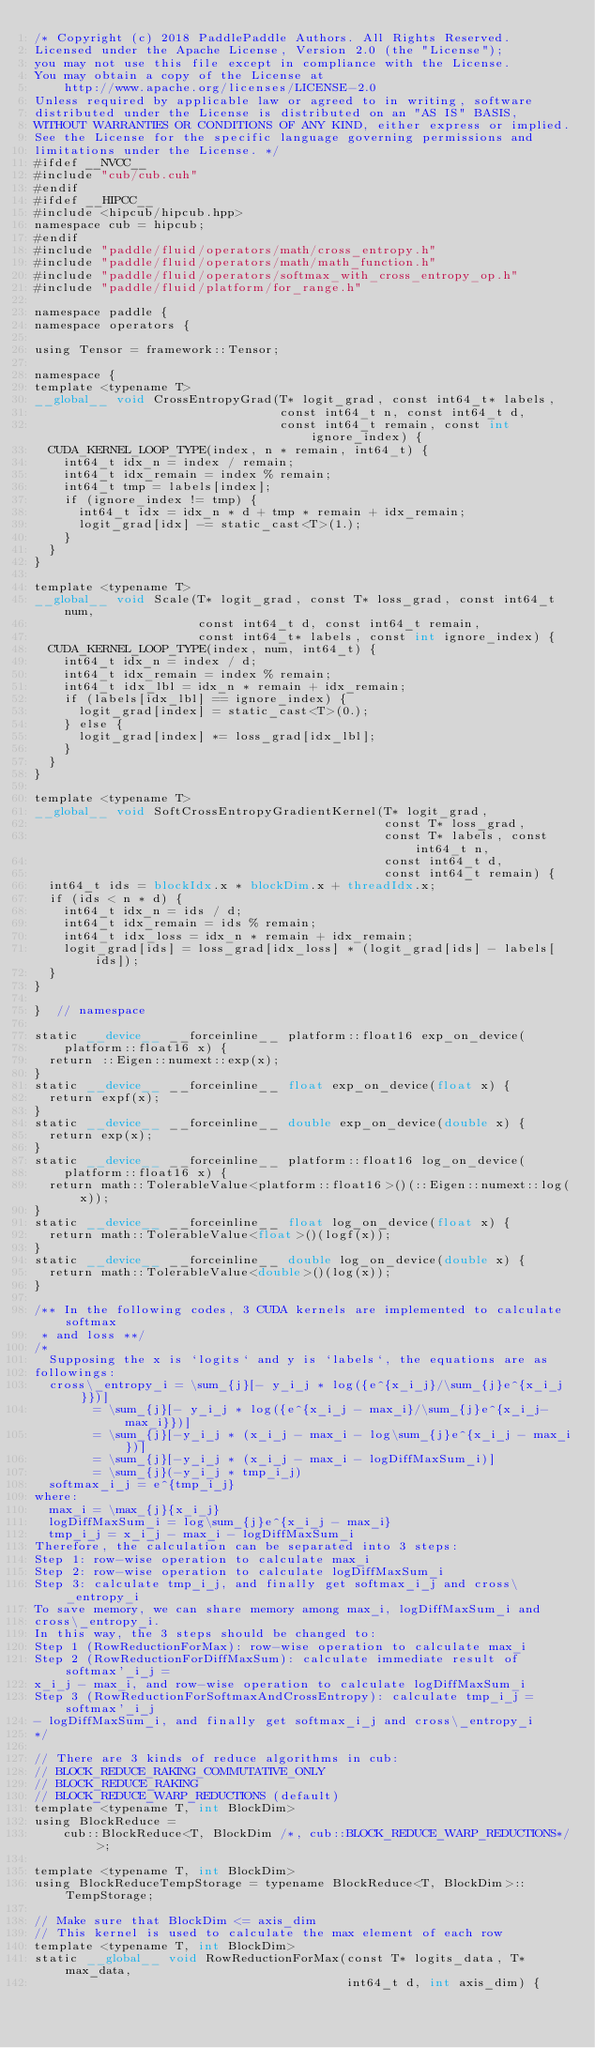<code> <loc_0><loc_0><loc_500><loc_500><_Cuda_>/* Copyright (c) 2018 PaddlePaddle Authors. All Rights Reserved.
Licensed under the Apache License, Version 2.0 (the "License");
you may not use this file except in compliance with the License.
You may obtain a copy of the License at
    http://www.apache.org/licenses/LICENSE-2.0
Unless required by applicable law or agreed to in writing, software
distributed under the License is distributed on an "AS IS" BASIS,
WITHOUT WARRANTIES OR CONDITIONS OF ANY KIND, either express or implied.
See the License for the specific language governing permissions and
limitations under the License. */
#ifdef __NVCC__
#include "cub/cub.cuh"
#endif
#ifdef __HIPCC__
#include <hipcub/hipcub.hpp>
namespace cub = hipcub;
#endif
#include "paddle/fluid/operators/math/cross_entropy.h"
#include "paddle/fluid/operators/math/math_function.h"
#include "paddle/fluid/operators/softmax_with_cross_entropy_op.h"
#include "paddle/fluid/platform/for_range.h"

namespace paddle {
namespace operators {

using Tensor = framework::Tensor;

namespace {
template <typename T>
__global__ void CrossEntropyGrad(T* logit_grad, const int64_t* labels,
                                 const int64_t n, const int64_t d,
                                 const int64_t remain, const int ignore_index) {
  CUDA_KERNEL_LOOP_TYPE(index, n * remain, int64_t) {
    int64_t idx_n = index / remain;
    int64_t idx_remain = index % remain;
    int64_t tmp = labels[index];
    if (ignore_index != tmp) {
      int64_t idx = idx_n * d + tmp * remain + idx_remain;
      logit_grad[idx] -= static_cast<T>(1.);
    }
  }
}

template <typename T>
__global__ void Scale(T* logit_grad, const T* loss_grad, const int64_t num,
                      const int64_t d, const int64_t remain,
                      const int64_t* labels, const int ignore_index) {
  CUDA_KERNEL_LOOP_TYPE(index, num, int64_t) {
    int64_t idx_n = index / d;
    int64_t idx_remain = index % remain;
    int64_t idx_lbl = idx_n * remain + idx_remain;
    if (labels[idx_lbl] == ignore_index) {
      logit_grad[index] = static_cast<T>(0.);
    } else {
      logit_grad[index] *= loss_grad[idx_lbl];
    }
  }
}

template <typename T>
__global__ void SoftCrossEntropyGradientKernel(T* logit_grad,
                                               const T* loss_grad,
                                               const T* labels, const int64_t n,
                                               const int64_t d,
                                               const int64_t remain) {
  int64_t ids = blockIdx.x * blockDim.x + threadIdx.x;
  if (ids < n * d) {
    int64_t idx_n = ids / d;
    int64_t idx_remain = ids % remain;
    int64_t idx_loss = idx_n * remain + idx_remain;
    logit_grad[ids] = loss_grad[idx_loss] * (logit_grad[ids] - labels[ids]);
  }
}

}  // namespace

static __device__ __forceinline__ platform::float16 exp_on_device(
    platform::float16 x) {
  return ::Eigen::numext::exp(x);
}
static __device__ __forceinline__ float exp_on_device(float x) {
  return expf(x);
}
static __device__ __forceinline__ double exp_on_device(double x) {
  return exp(x);
}
static __device__ __forceinline__ platform::float16 log_on_device(
    platform::float16 x) {
  return math::TolerableValue<platform::float16>()(::Eigen::numext::log(x));
}
static __device__ __forceinline__ float log_on_device(float x) {
  return math::TolerableValue<float>()(logf(x));
}
static __device__ __forceinline__ double log_on_device(double x) {
  return math::TolerableValue<double>()(log(x));
}

/** In the following codes, 3 CUDA kernels are implemented to calculate softmax
 * and loss **/
/*
  Supposing the x is `logits` and y is `labels`, the equations are as
followings:
  cross\_entropy_i = \sum_{j}[- y_i_j * log({e^{x_i_j}/\sum_{j}e^{x_i_j}})]
        = \sum_{j}[- y_i_j * log({e^{x_i_j - max_i}/\sum_{j}e^{x_i_j-max_i}})]
        = \sum_{j}[-y_i_j * (x_i_j - max_i - log\sum_{j}e^{x_i_j - max_i})]
        = \sum_{j}[-y_i_j * (x_i_j - max_i - logDiffMaxSum_i)]
        = \sum_{j}(-y_i_j * tmp_i_j)
  softmax_i_j = e^{tmp_i_j}
where:
  max_i = \max_{j}{x_i_j}
  logDiffMaxSum_i = log\sum_{j}e^{x_i_j - max_i}
  tmp_i_j = x_i_j - max_i - logDiffMaxSum_i
Therefore, the calculation can be separated into 3 steps:
Step 1: row-wise operation to calculate max_i
Step 2: row-wise operation to calculate logDiffMaxSum_i
Step 3: calculate tmp_i_j, and finally get softmax_i_j and cross\_entropy_i
To save memory, we can share memory among max_i, logDiffMaxSum_i and
cross\_entropy_i.
In this way, the 3 steps should be changed to:
Step 1 (RowReductionForMax): row-wise operation to calculate max_i
Step 2 (RowReductionForDiffMaxSum): calculate immediate result of softmax'_i_j =
x_i_j - max_i, and row-wise operation to calculate logDiffMaxSum_i
Step 3 (RowReductionForSoftmaxAndCrossEntropy): calculate tmp_i_j = softmax'_i_j
- logDiffMaxSum_i, and finally get softmax_i_j and cross\_entropy_i
*/

// There are 3 kinds of reduce algorithms in cub:
// BLOCK_REDUCE_RAKING_COMMUTATIVE_ONLY
// BLOCK_REDUCE_RAKING
// BLOCK_REDUCE_WARP_REDUCTIONS (default)
template <typename T, int BlockDim>
using BlockReduce =
    cub::BlockReduce<T, BlockDim /*, cub::BLOCK_REDUCE_WARP_REDUCTIONS*/>;

template <typename T, int BlockDim>
using BlockReduceTempStorage = typename BlockReduce<T, BlockDim>::TempStorage;

// Make sure that BlockDim <= axis_dim
// This kernel is used to calculate the max element of each row
template <typename T, int BlockDim>
static __global__ void RowReductionForMax(const T* logits_data, T* max_data,
                                          int64_t d, int axis_dim) {</code> 